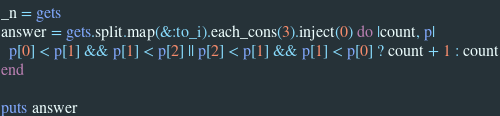Convert code to text. <code><loc_0><loc_0><loc_500><loc_500><_Ruby_>_n = gets
answer = gets.split.map(&:to_i).each_cons(3).inject(0) do |count, p|
  p[0] < p[1] && p[1] < p[2] || p[2] < p[1] && p[1] < p[0] ? count + 1 : count
end

puts answer</code> 